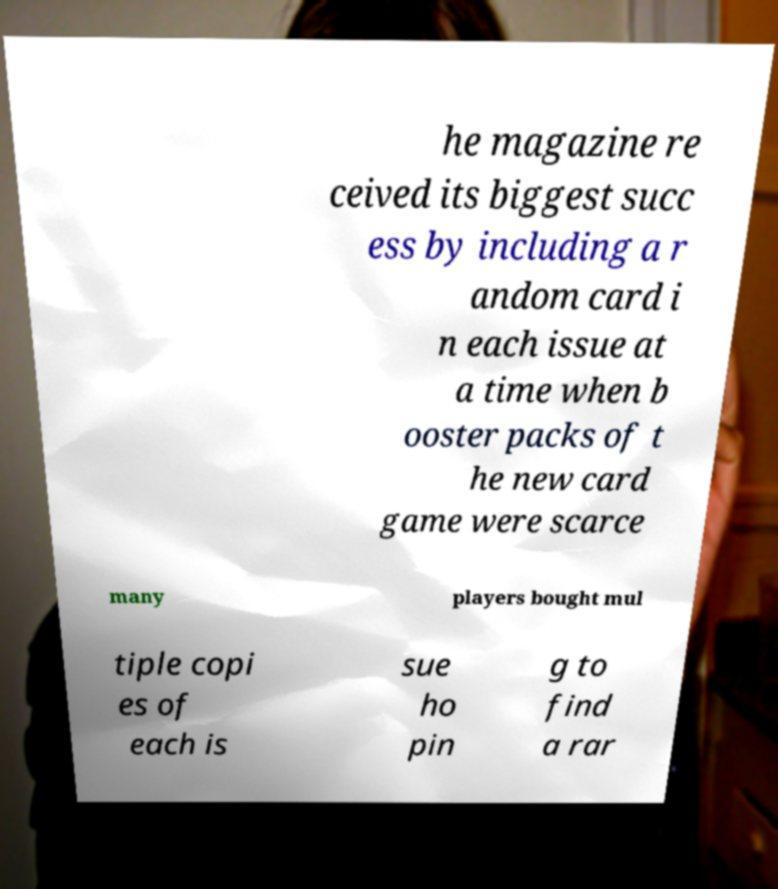Please read and relay the text visible in this image. What does it say? he magazine re ceived its biggest succ ess by including a r andom card i n each issue at a time when b ooster packs of t he new card game were scarce many players bought mul tiple copi es of each is sue ho pin g to find a rar 